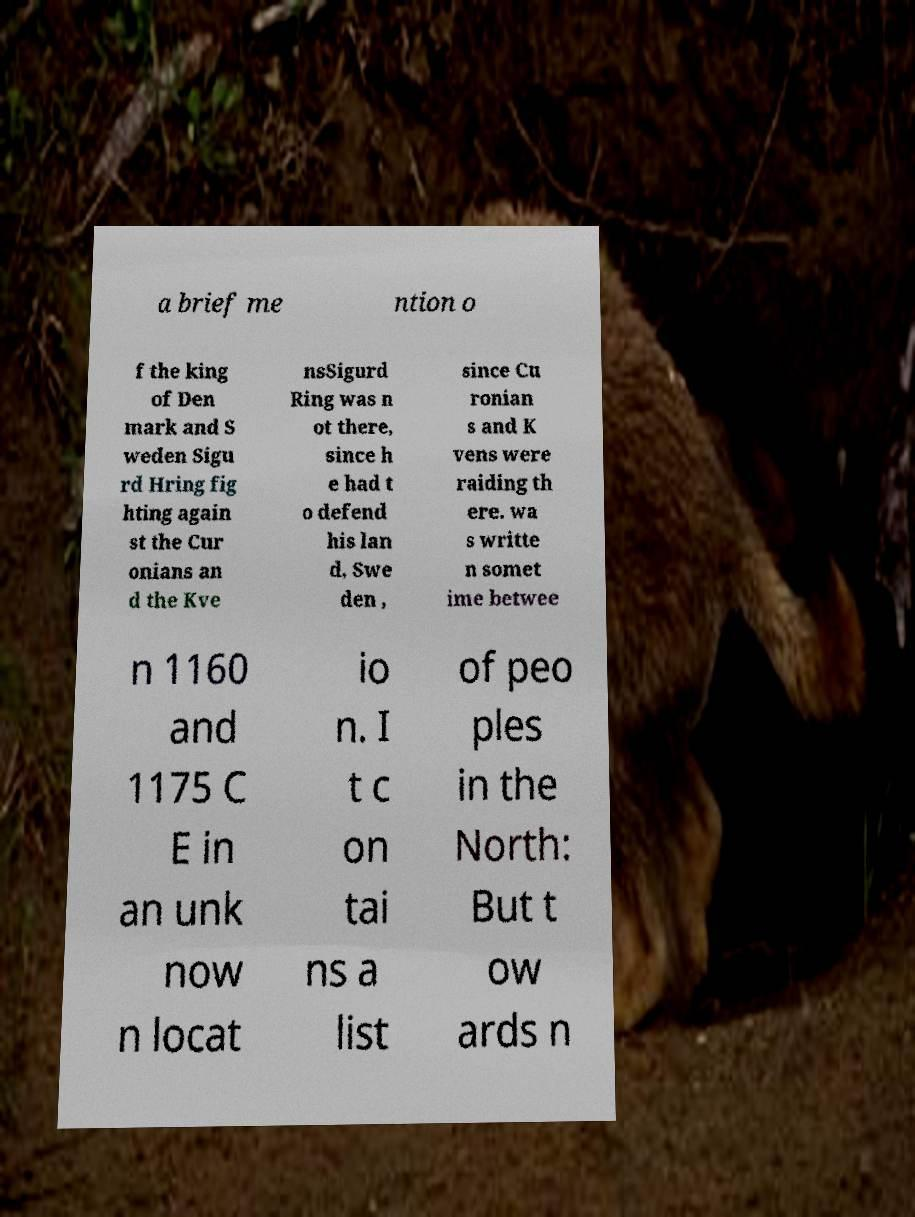There's text embedded in this image that I need extracted. Can you transcribe it verbatim? a brief me ntion o f the king of Den mark and S weden Sigu rd Hring fig hting again st the Cur onians an d the Kve nsSigurd Ring was n ot there, since h e had t o defend his lan d, Swe den , since Cu ronian s and K vens were raiding th ere. wa s writte n somet ime betwee n 1160 and 1175 C E in an unk now n locat io n. I t c on tai ns a list of peo ples in the North: But t ow ards n 